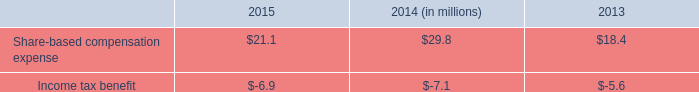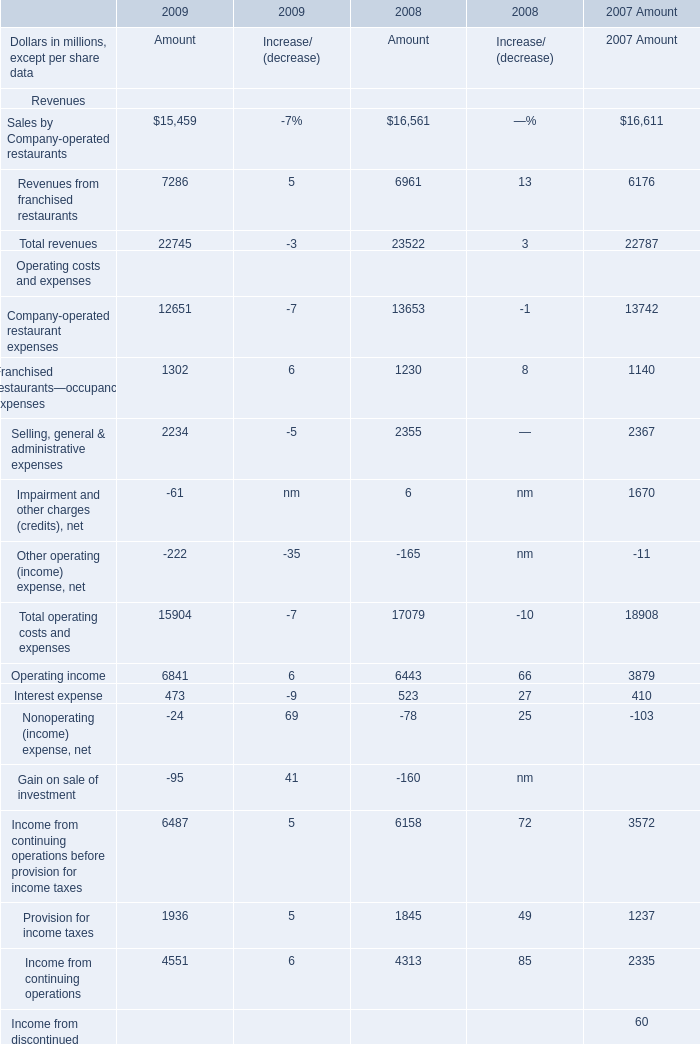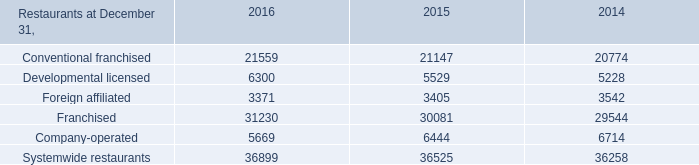Which the difference between the proportion of Sales by Company-operated restaurants in 2009 for Amount and that of Conventional franchised in 2016 ? 
Computations: (15459 / 21559)
Answer: 0.71706. 